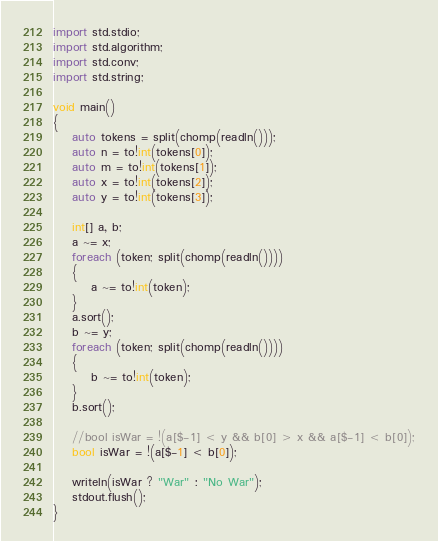<code> <loc_0><loc_0><loc_500><loc_500><_D_>import std.stdio;
import std.algorithm;
import std.conv;
import std.string;

void main()
{
	auto tokens = split(chomp(readln()));
	auto n = to!int(tokens[0]);
	auto m = to!int(tokens[1]);
	auto x = to!int(tokens[2]);
	auto y = to!int(tokens[3]);

	int[] a, b;
	a ~= x;
	foreach (token; split(chomp(readln())))
	{
		a ~= to!int(token);
	}
	a.sort();
	b ~= y;
	foreach (token; split(chomp(readln())))
	{
		b ~= to!int(token);
	}
	b.sort();

	//bool isWar = !(a[$-1] < y && b[0] > x && a[$-1] < b[0]);
	bool isWar = !(a[$-1] < b[0]);
	
	writeln(isWar ? "War" : "No War");
	stdout.flush();
}</code> 